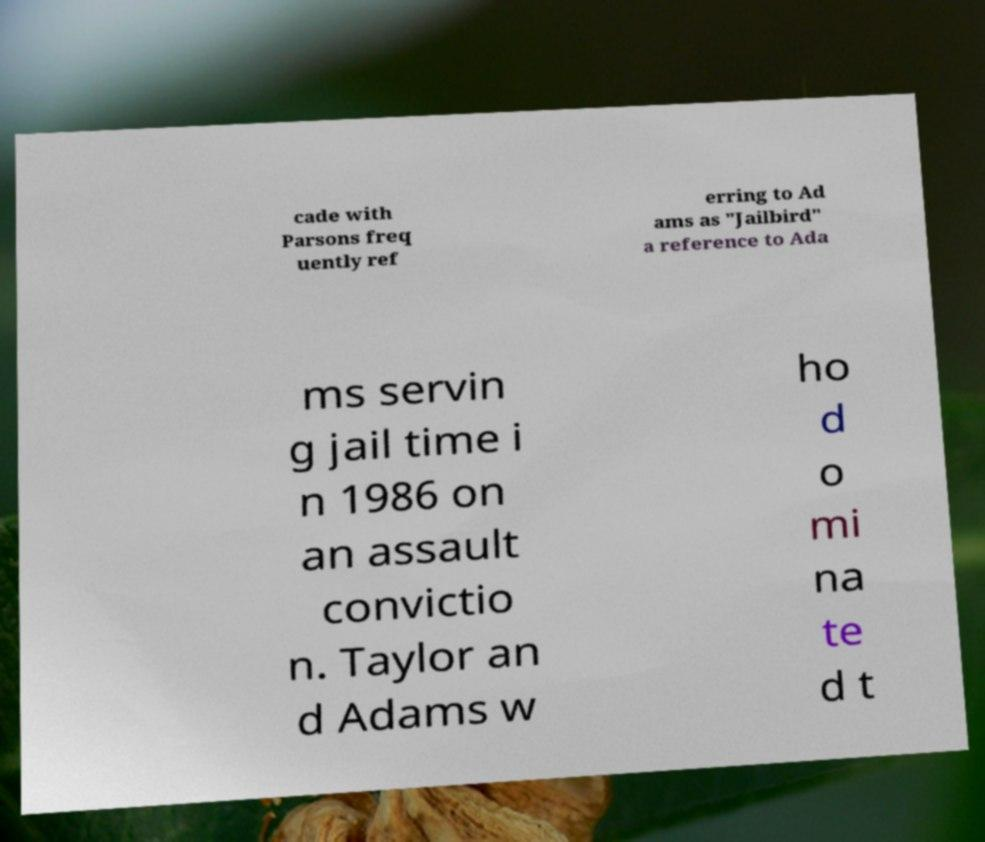For documentation purposes, I need the text within this image transcribed. Could you provide that? cade with Parsons freq uently ref erring to Ad ams as "Jailbird" a reference to Ada ms servin g jail time i n 1986 on an assault convictio n. Taylor an d Adams w ho d o mi na te d t 